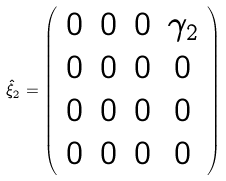Convert formula to latex. <formula><loc_0><loc_0><loc_500><loc_500>\hat { \mathcal { \xi } } _ { 2 } = \left ( \begin{array} { c c c c c c c } 0 & 0 & 0 & \gamma _ { 2 } \\ 0 & 0 & 0 & 0 \\ 0 & 0 & 0 & 0 \\ 0 & 0 & 0 & 0 \\ \end{array} \right )</formula> 